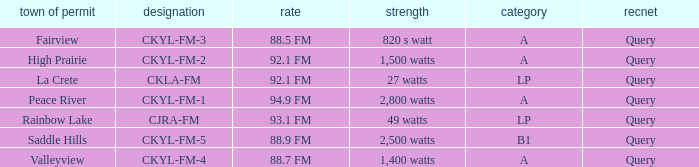5 fm frequency? 820 s watt. 